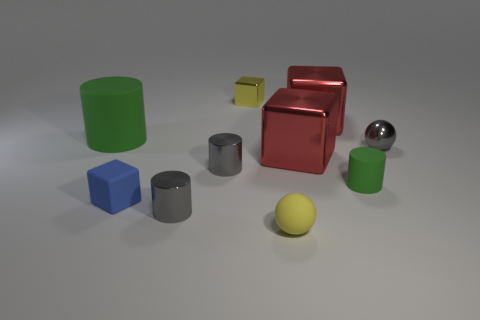What number of gray matte things have the same size as the yellow rubber sphere?
Your answer should be very brief. 0. Are there fewer small metal cubes that are right of the tiny green cylinder than small yellow cylinders?
Give a very brief answer. No. How many tiny gray metal objects are left of the yellow ball?
Your answer should be compact. 2. How big is the matte cylinder that is on the left side of the cube that is in front of the cylinder on the right side of the tiny rubber sphere?
Offer a terse response. Large. Do the small yellow metal object and the tiny rubber object on the left side of the yellow metallic block have the same shape?
Provide a succinct answer. Yes. What size is the yellow ball that is the same material as the tiny blue thing?
Keep it short and to the point. Small. Is there any other thing that is the same color as the metal ball?
Give a very brief answer. Yes. There is a tiny cube that is in front of the matte cylinder on the right side of the small blue block that is in front of the small gray metallic ball; what is it made of?
Provide a succinct answer. Rubber. Is the matte ball the same color as the small metallic cube?
Your response must be concise. Yes. What number of things are large green metallic cylinders or green cylinders right of the yellow ball?
Make the answer very short. 1. 